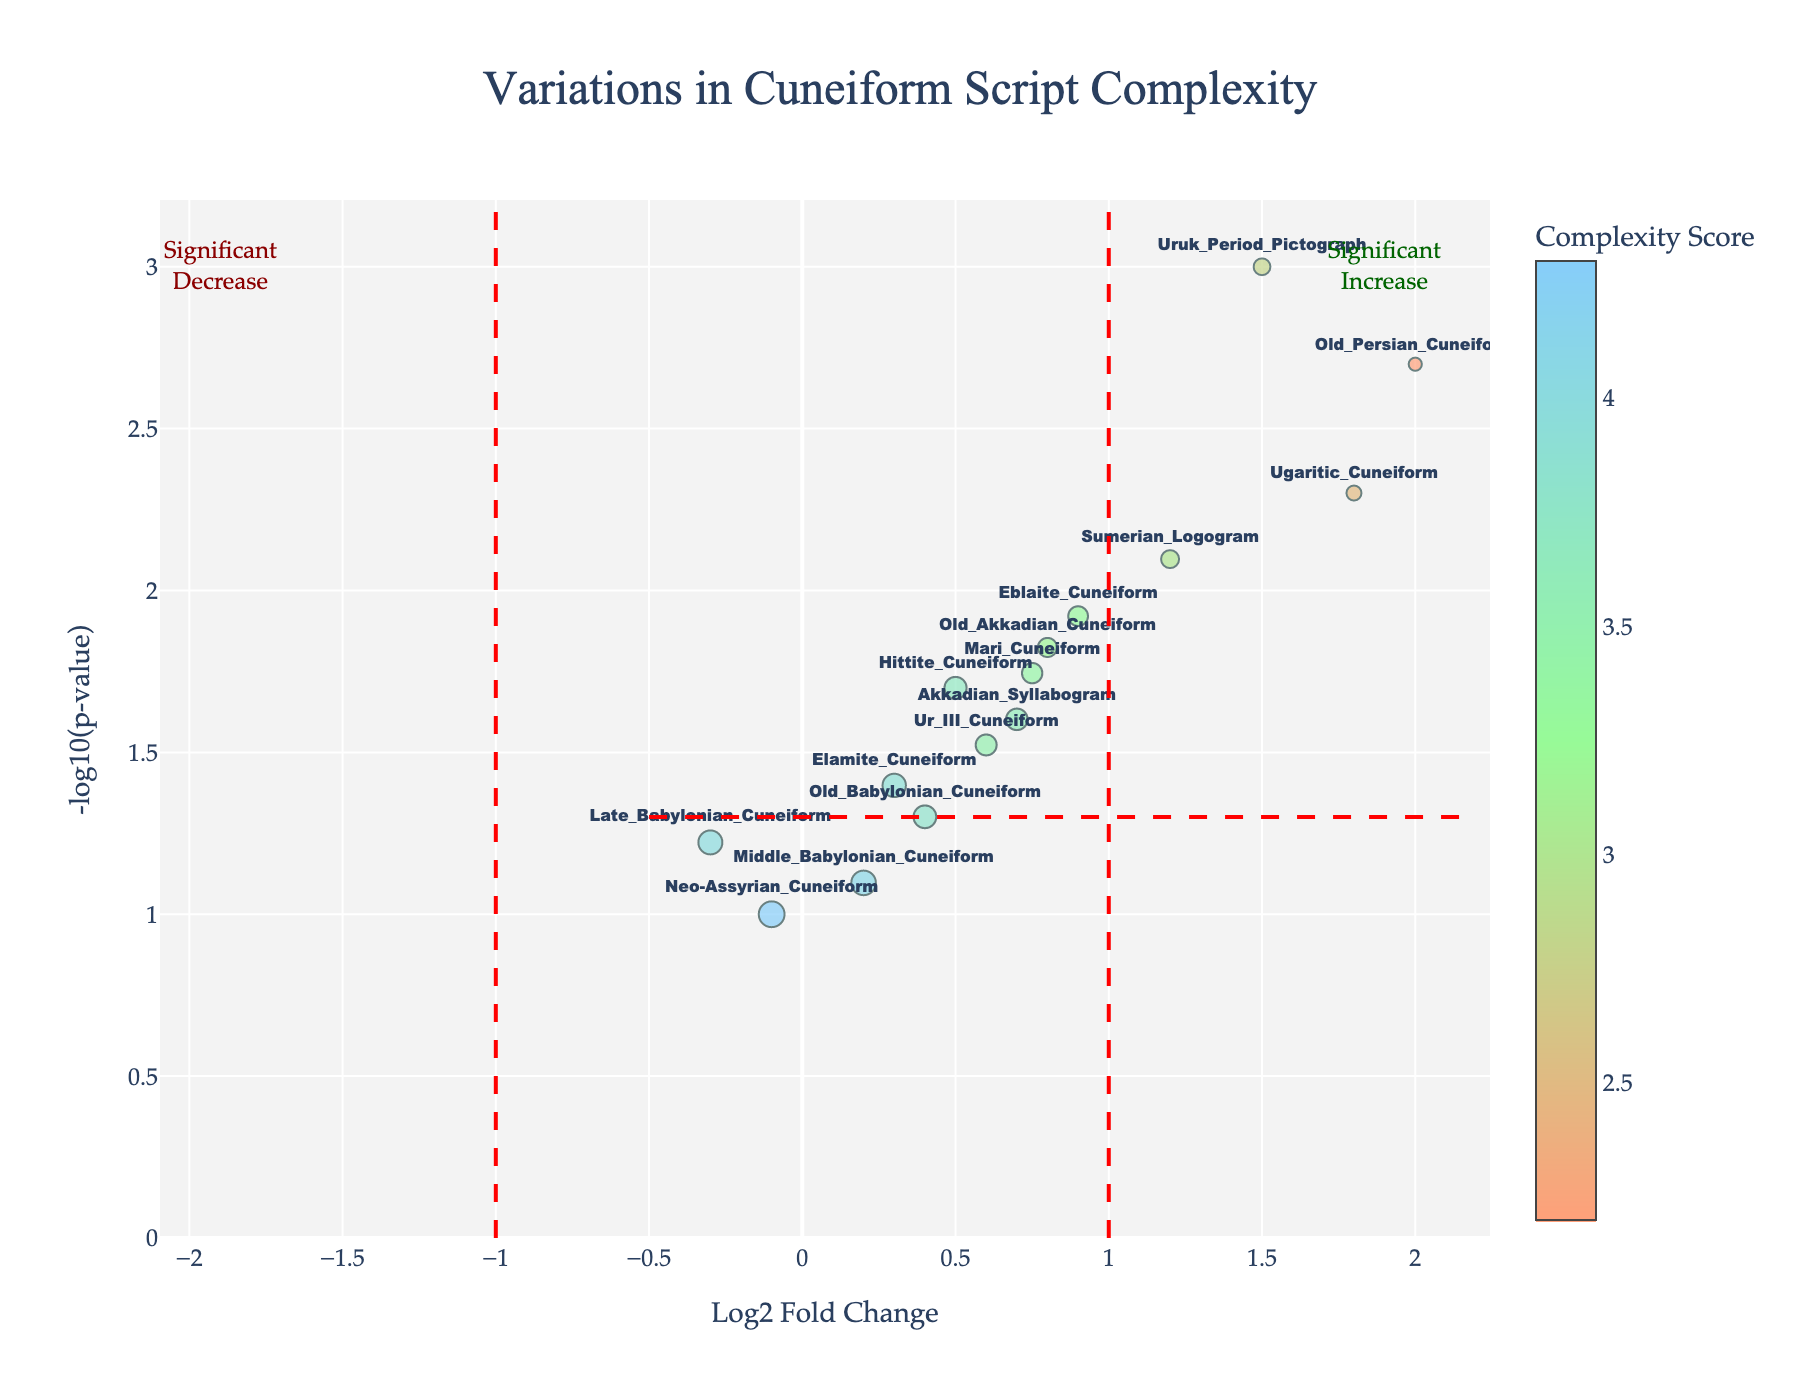What is the title of the plot? The title of the plot is displayed at the top center of the figure. It reads "Variations in Cuneiform Script Complexity".
Answer: Variations in Cuneiform Script Complexity How many symbols have a -log10(p-value) greater than 1.3? To determine this, we look at the y-axis for a -log10(p-value) greater than 1.3 and count the number of points above this threshold.
Answer: 9 Which symbol has the highest complexity score? By examining the color bar and the size of the markers, we identify that the "Neo-Assyrian Cuneiform" has the highest complexity score of 4.3.
Answer: Neo-Assyrian Cuneiform What is the log2 fold change and -log10(p-value) for the "Ugaritic Cuneiform"? The "Ugaritic Cuneiform" marker shows a log2 fold change of 1.8 and a -log10(p-value) of approximately 2.3, based on the axis values and hover information.
Answer: Log2 Fold Change: 1.8, -log10(p-value): 2.3 Which symbols are significantly increased? Symbols are considered significantly increased if they lie to the right of the vertical line at x=1 and above the horizontal line at y=1.3. The symbols "Old Persian Cuneiform", "Ugaritic Cuneiform", "Uruk Period Pictograph", and "Sumerian Logogram" meet these criteria.
Answer: Old Persian Cuneiform, Ugaritic Cuneiform, Uruk Period Pictograph, Sumerian Logogram Compare the complexity scores of "Old Akkadian Cuneiform" and "Elamite Cuneiform". Which one is more complex? "Old Akkadian Cuneiform" has a complexity score of 3.2, while "Elamite Cuneiform" has a complexity score of 3.9. Therefore, "Elamite Cuneiform" is more complex.
Answer: Elamite Cuneiform Which symbol has the lowest log2 fold change? By examining the markers on the x-axis, the "Neo-Assyrian Cuneiform" has the lowest log2 fold change at -0.1.
Answer: Neo-Assyrian Cuneiform How does the complexity score of "Hittite Cuneiform" compare to that of "Mari Cuneiform"? The complexity score of "Hittite Cuneiform" is 3.7, while "Mari Cuneiform" is 3.4. Thus, "Hittite Cuneiform" has a higher complexity score than "Mari Cuneiform".
Answer: "Hittite Cuneiform" is more complex What is the approximate -log10(p-value) for the "Old Babylonian Cuneiform"? By locating the "Old Babylonian Cuneiform" marker on the plot, its approximate -log10(p-value) is just under 1.3, around 1.
Answer: 1 Which symbols fall under the significant decrease category? Symbols are considered significantly decreased if they lie to the left of the vertical line at x=-1 and above the horizontal line at y=1.3. No symbols in the plot meet both criteria.
Answer: None 